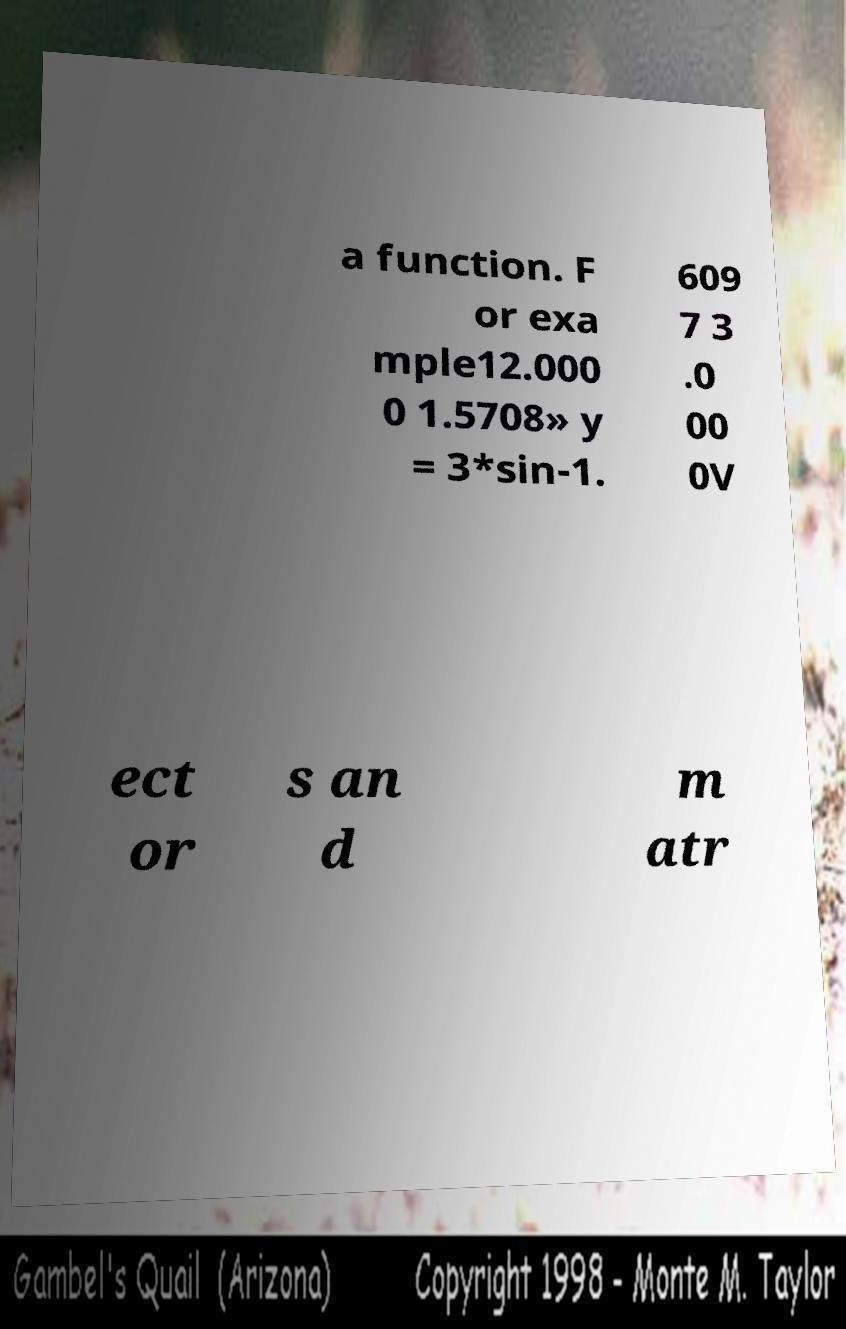There's text embedded in this image that I need extracted. Can you transcribe it verbatim? a function. F or exa mple12.000 0 1.5708» y = 3*sin-1. 609 7 3 .0 00 0V ect or s an d m atr 